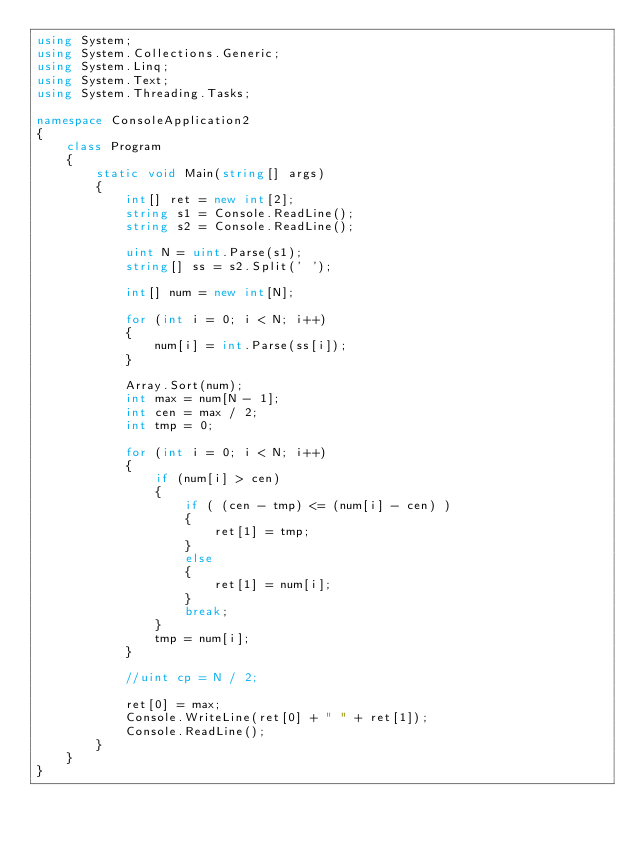Convert code to text. <code><loc_0><loc_0><loc_500><loc_500><_C#_>using System;
using System.Collections.Generic;
using System.Linq;
using System.Text;
using System.Threading.Tasks;

namespace ConsoleApplication2
{
    class Program
    {
        static void Main(string[] args)
        {
            int[] ret = new int[2];
            string s1 = Console.ReadLine();
            string s2 = Console.ReadLine();

            uint N = uint.Parse(s1);
            string[] ss = s2.Split(' ');

            int[] num = new int[N];

            for (int i = 0; i < N; i++)
            {
                num[i] = int.Parse(ss[i]);
            }

            Array.Sort(num);
            int max = num[N - 1];
            int cen = max / 2;
            int tmp = 0;

            for (int i = 0; i < N; i++)
            {
                if (num[i] > cen)
                {
                    if ( (cen - tmp) <= (num[i] - cen) )
                    {
                        ret[1] = tmp;
                    }
                    else
                    {
                        ret[1] = num[i];
                    }
                    break;
                }
                tmp = num[i];
            }

            //uint cp = N / 2;

            ret[0] = max;
            Console.WriteLine(ret[0] + " " + ret[1]);
            Console.ReadLine();
        }
    }
}
</code> 